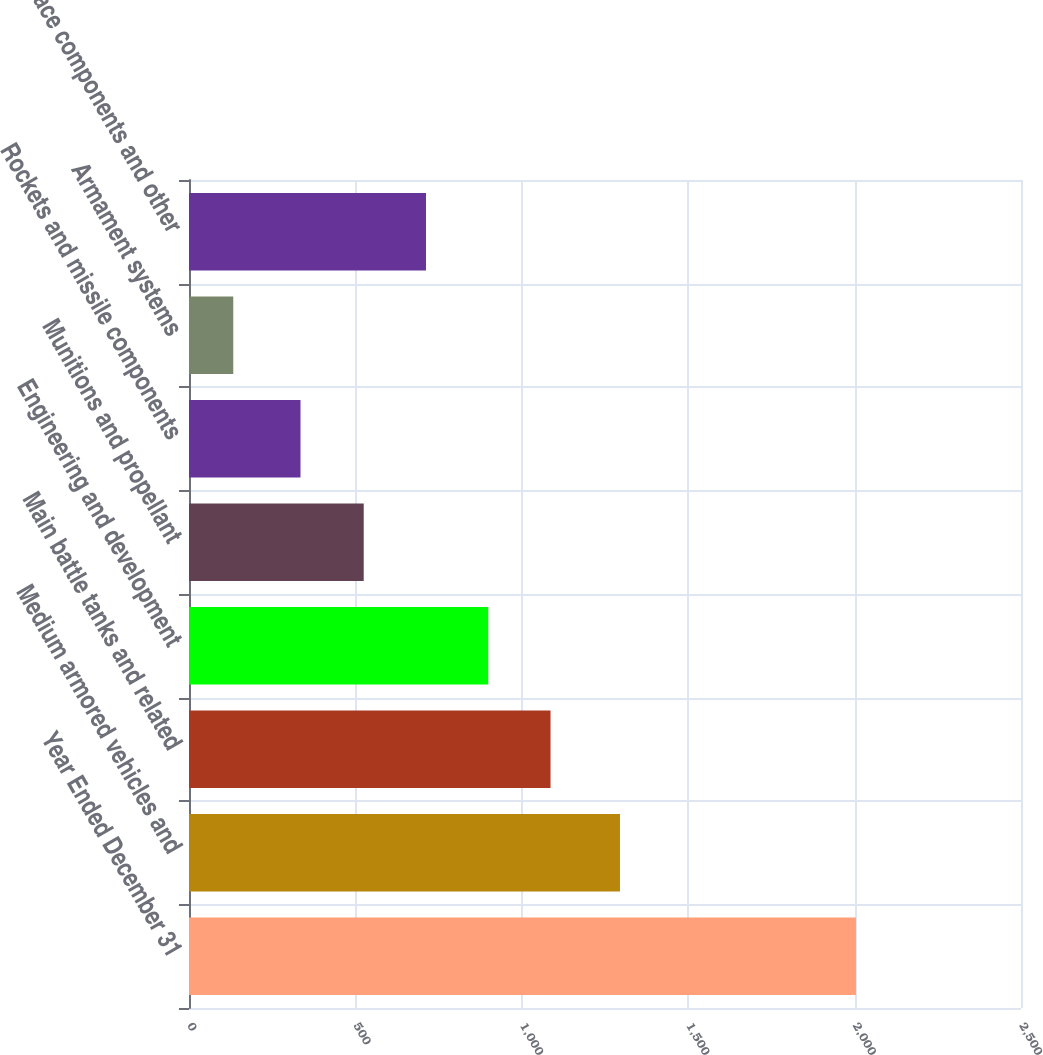Convert chart to OTSL. <chart><loc_0><loc_0><loc_500><loc_500><bar_chart><fcel>Year Ended December 31<fcel>Medium armored vehicles and<fcel>Main battle tanks and related<fcel>Engineering and development<fcel>Munitions and propellant<fcel>Rockets and missile components<fcel>Armament systems<fcel>Aerospace components and other<nl><fcel>2004<fcel>1295<fcel>1086.3<fcel>899.2<fcel>525<fcel>335<fcel>133<fcel>712.1<nl></chart> 